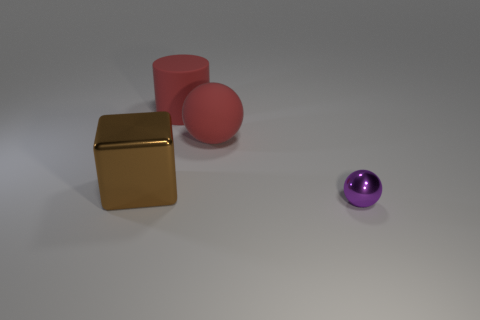Is there any other thing that is the same size as the purple object?
Offer a terse response. No. Is the color of the cylinder the same as the sphere that is behind the large brown metallic thing?
Make the answer very short. Yes. Is the number of big red things that are on the right side of the large cylinder greater than the number of brown shiny balls?
Make the answer very short. Yes. How many large red things are in front of the rubber object to the left of the ball to the left of the small purple shiny ball?
Your answer should be compact. 1. There is a large red rubber thing that is in front of the large matte cylinder; is its shape the same as the purple shiny object?
Ensure brevity in your answer.  Yes. There is a object that is in front of the big metal cube; what is it made of?
Give a very brief answer. Metal. There is a large object that is both to the left of the red matte sphere and right of the brown metal thing; what is its shape?
Give a very brief answer. Cylinder. What is the big brown block made of?
Your answer should be compact. Metal. How many spheres are small red things or purple metallic objects?
Your answer should be compact. 1. Is the material of the red cylinder the same as the brown cube?
Offer a very short reply. No. 